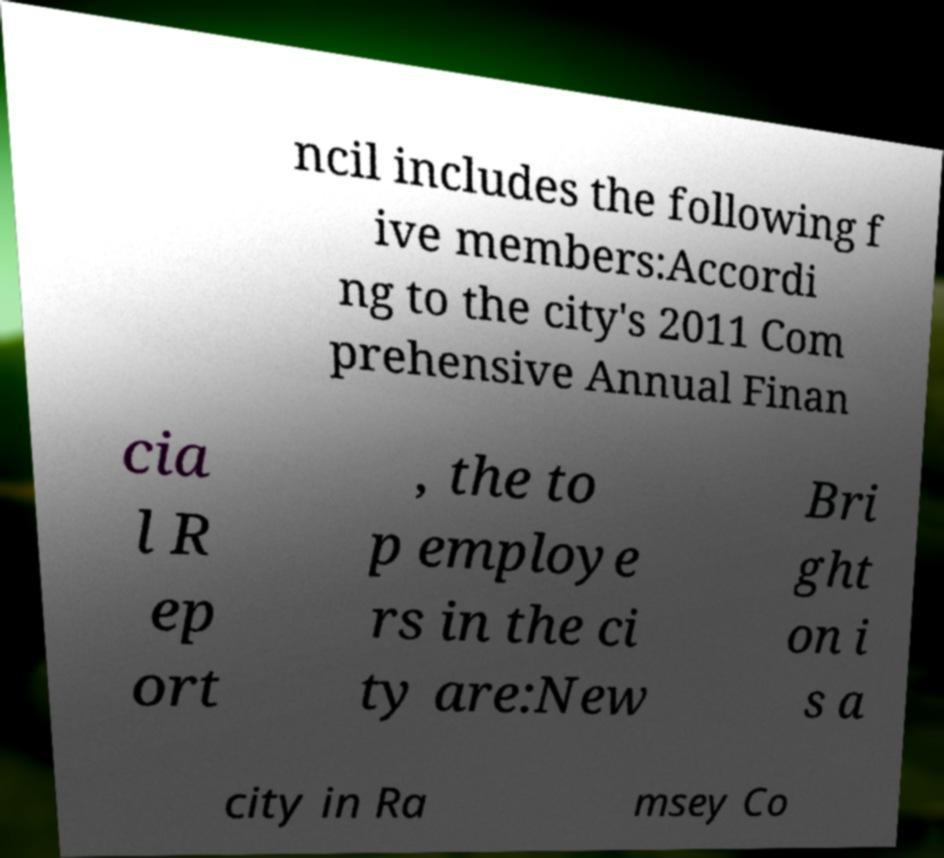There's text embedded in this image that I need extracted. Can you transcribe it verbatim? ncil includes the following f ive members:Accordi ng to the city's 2011 Com prehensive Annual Finan cia l R ep ort , the to p employe rs in the ci ty are:New Bri ght on i s a city in Ra msey Co 